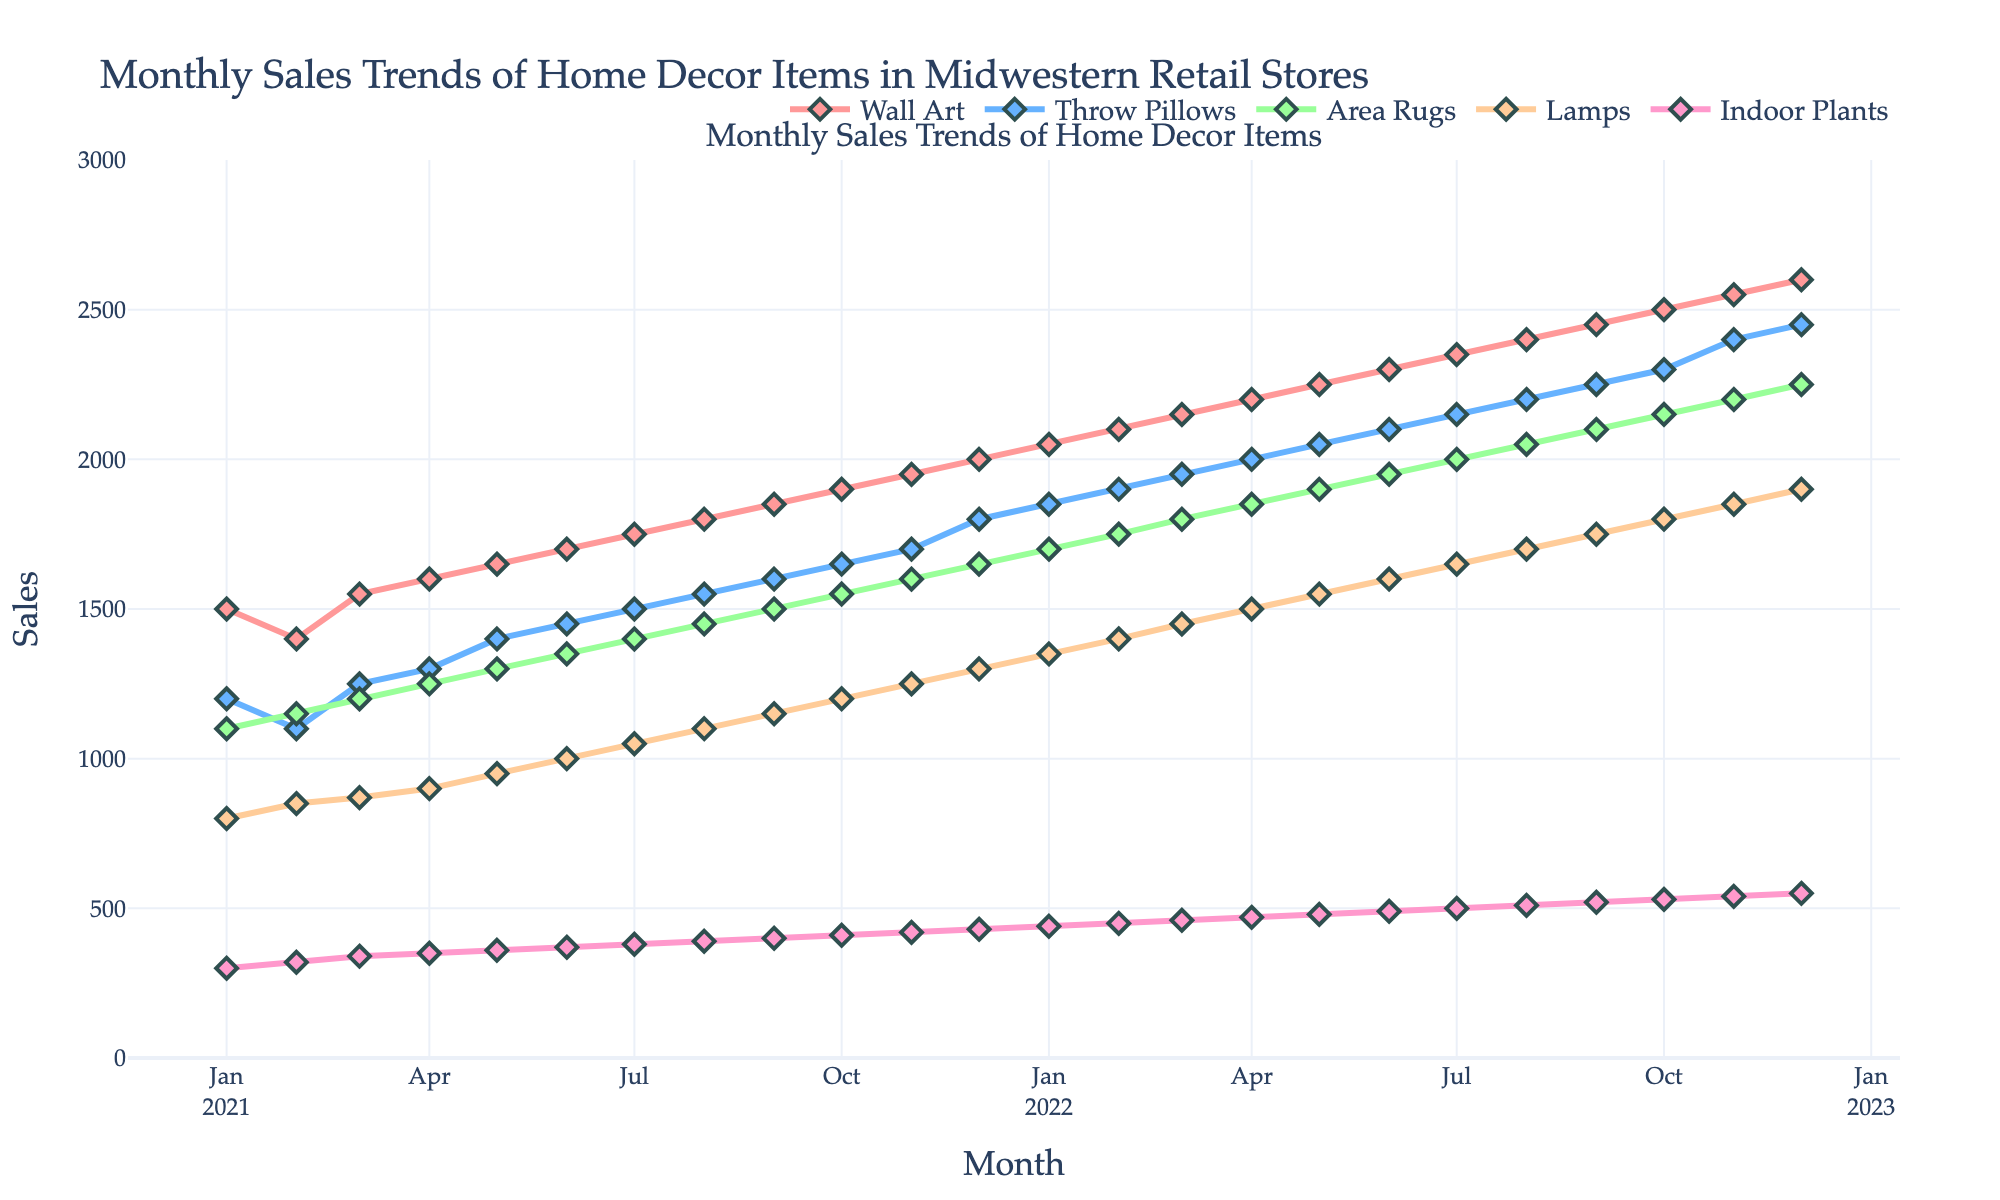What is the title of the plot? The title of the plot is displayed at the top of the figure.
Answer: Monthly Sales Trends of Home Decor Items in Midwestern Retail Stores How many categories of home decor items are plotted? You can count the different lines and their labels in the legend to determine the number of categories. There are five categories: Wall Art, Throw Pillows, Area Rugs, Lamps, and Indoor Plants.
Answer: 5 What color represents the sales of Throw Pillows? Look for the legend where each item is listed with a corresponding color. Throw Pillows are represented by a blue color.
Answer: Blue Which home decor item had the highest sales in December 2022? By examining the values at the end of 2022 on the plot, you can see which line reached the highest point. Indoor Plants had the highest sales, reaching 550.
Answer: Indoor Plants What are the sales values for Area Rugs and Wall Art in June 2021? Find the intersection of the June 2021 vertical line with the Area Rugs and Wall Art lines. Sales for Area Rugs are 1350 and for Wall Art are 1700.
Answer: Area Rugs: 1350, Wall Art: 1700 Which item showed the most consistent growth over the period? By looking at the smoothness and uniformity of the upward trend, Wall Art shows the most consistent growth as the line is steadily increasing.
Answer: Wall Art What is the difference in sales of Lamps between January 2021 and January 2022? Check the plot for the Lamp sales in January 2021 and January 2022, then subtract the two values. Sales in January 2021 were 800 and in January 2022 were 1350. The difference is 1350 - 800 = 550.
Answer: 550 Which month saw the highest sales increase for Throw Pillows compared to the previous month? Observe the plot and look for the steepest slope line in the Throw Pillows category. The highest increase appears between October 2022 and November 2022.
Answer: November 2022 What is the average sales value for Indoor Plants throughout 2021? Find the sales values for Indoor Plants for each month in 2021, sum them up, and divide by the number of months (12). The values are 300, 320, 340, 350, 360, 370, 380, 390, 400, 410, 420, 430. The sum is 4570, and the average is 4570 / 12 = 380.83.
Answer: 380.83 Is the time series for Lamps generally increasing, decreasing, or fluctuating? By examining the general trend of the Lamps' line in the plot, you can see it is generally increasing as the line goes up over time.
Answer: Increasing 